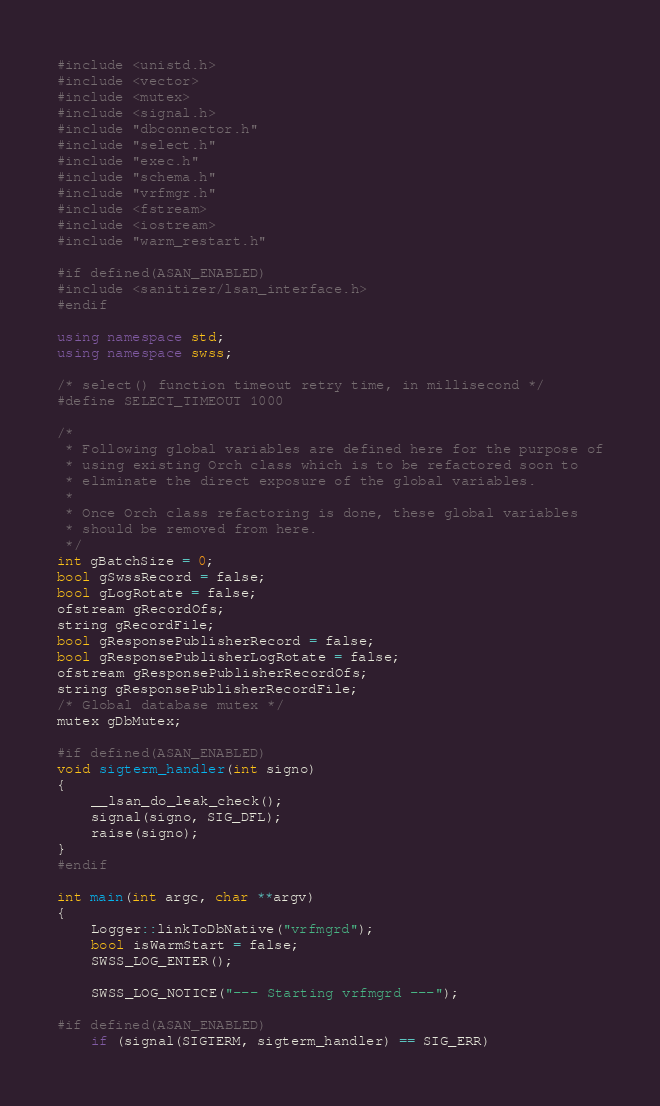Convert code to text. <code><loc_0><loc_0><loc_500><loc_500><_C++_>#include <unistd.h>
#include <vector>
#include <mutex>
#include <signal.h>
#include "dbconnector.h"
#include "select.h"
#include "exec.h"
#include "schema.h"
#include "vrfmgr.h"
#include <fstream>
#include <iostream>
#include "warm_restart.h"

#if defined(ASAN_ENABLED)
#include <sanitizer/lsan_interface.h>
#endif

using namespace std;
using namespace swss;

/* select() function timeout retry time, in millisecond */
#define SELECT_TIMEOUT 1000

/*
 * Following global variables are defined here for the purpose of
 * using existing Orch class which is to be refactored soon to
 * eliminate the direct exposure of the global variables.
 *
 * Once Orch class refactoring is done, these global variables
 * should be removed from here.
 */
int gBatchSize = 0;
bool gSwssRecord = false;
bool gLogRotate = false;
ofstream gRecordOfs;
string gRecordFile;
bool gResponsePublisherRecord = false;
bool gResponsePublisherLogRotate = false;
ofstream gResponsePublisherRecordOfs;
string gResponsePublisherRecordFile;
/* Global database mutex */
mutex gDbMutex;

#if defined(ASAN_ENABLED)
void sigterm_handler(int signo)
{
    __lsan_do_leak_check();
    signal(signo, SIG_DFL);
    raise(signo);
}
#endif

int main(int argc, char **argv)
{
    Logger::linkToDbNative("vrfmgrd");
    bool isWarmStart = false;
    SWSS_LOG_ENTER();

    SWSS_LOG_NOTICE("--- Starting vrfmgrd ---");

#if defined(ASAN_ENABLED)
    if (signal(SIGTERM, sigterm_handler) == SIG_ERR)</code> 